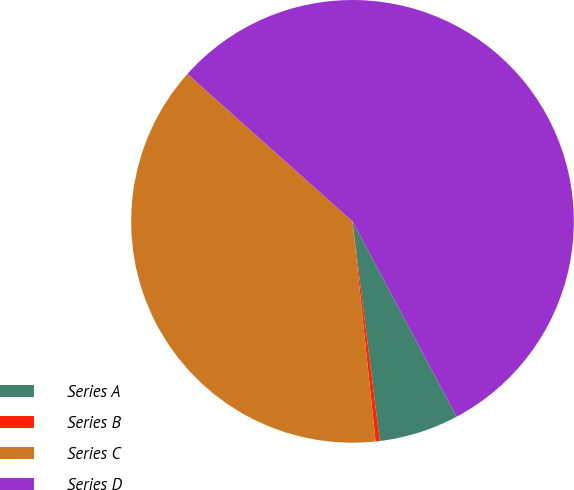<chart> <loc_0><loc_0><loc_500><loc_500><pie_chart><fcel>Series A<fcel>Series B<fcel>Series C<fcel>Series D<nl><fcel>5.83%<fcel>0.3%<fcel>38.27%<fcel>55.61%<nl></chart> 